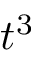<formula> <loc_0><loc_0><loc_500><loc_500>t ^ { 3 }</formula> 